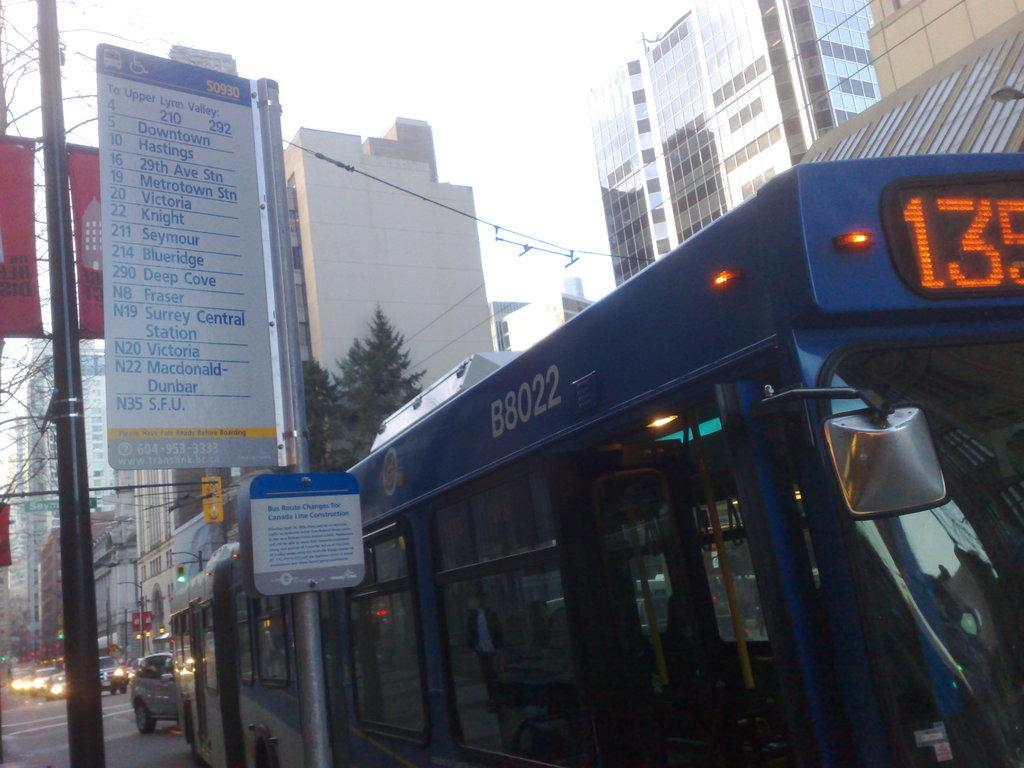Provide a one-sentence caption for the provided image. A blue bus with tall buildings surrounded it and the number 135 on top of the bus. 